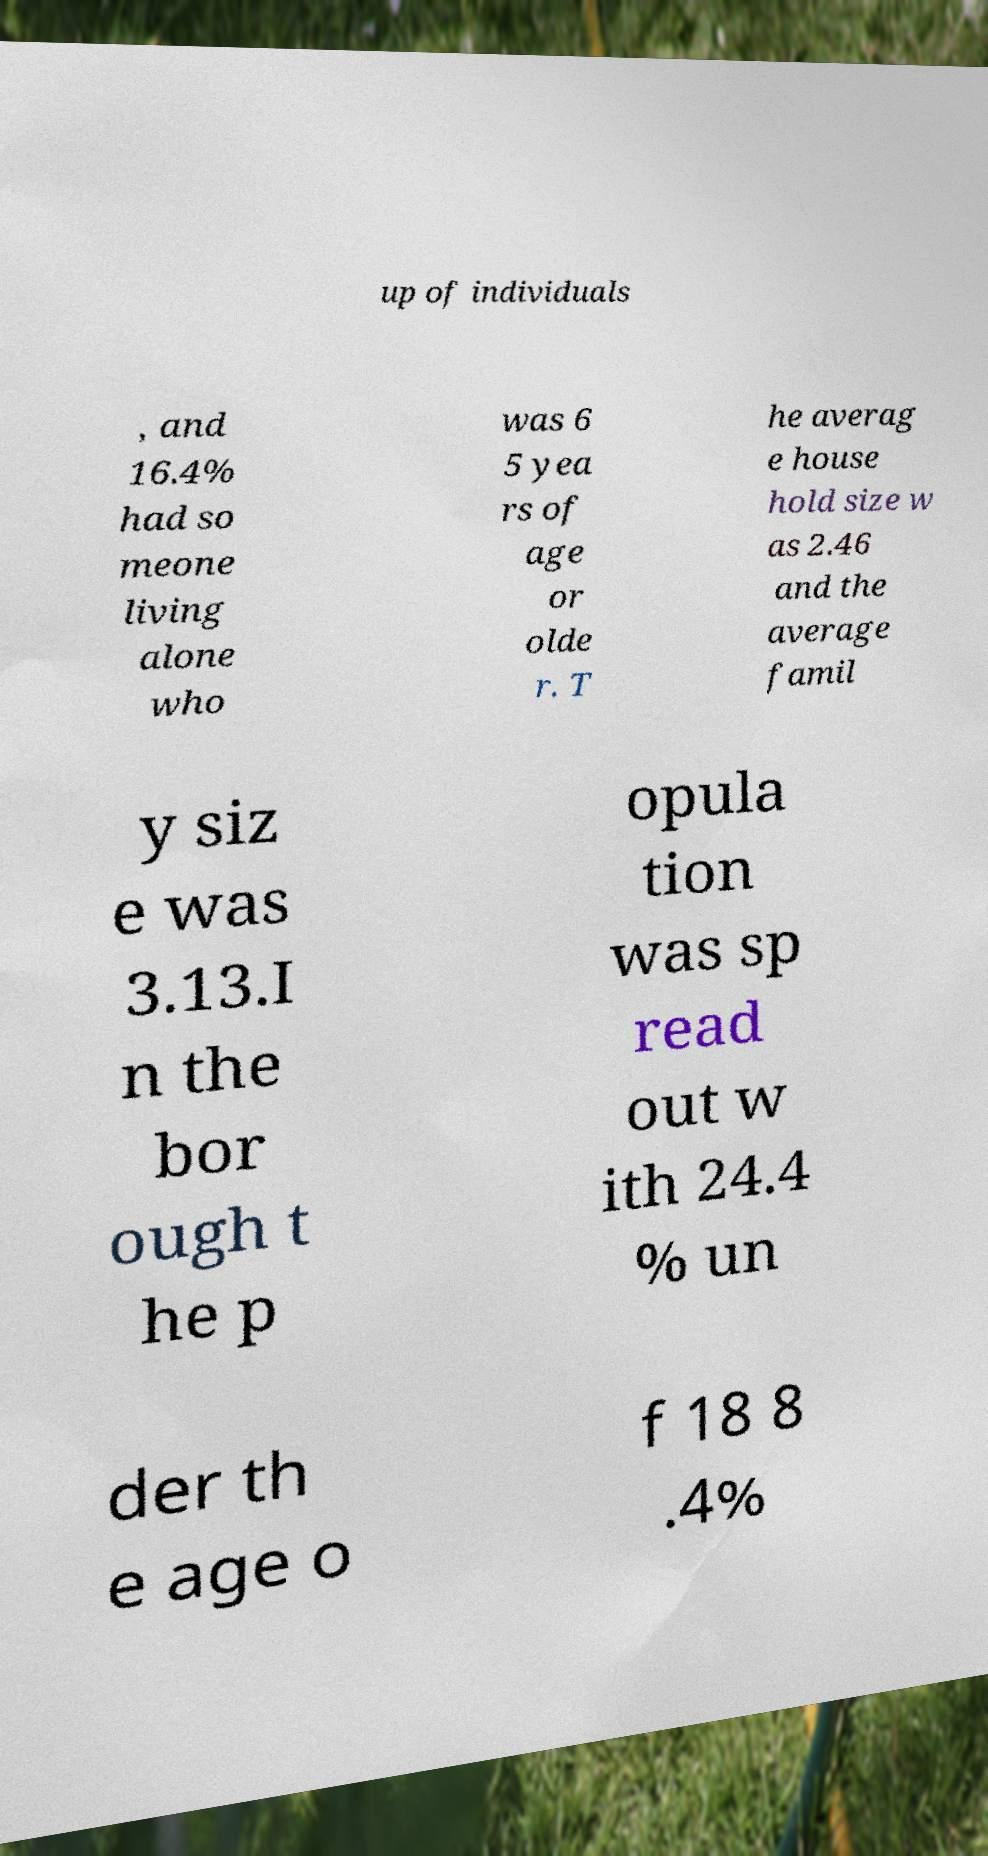Can you read and provide the text displayed in the image?This photo seems to have some interesting text. Can you extract and type it out for me? up of individuals , and 16.4% had so meone living alone who was 6 5 yea rs of age or olde r. T he averag e house hold size w as 2.46 and the average famil y siz e was 3.13.I n the bor ough t he p opula tion was sp read out w ith 24.4 % un der th e age o f 18 8 .4% 